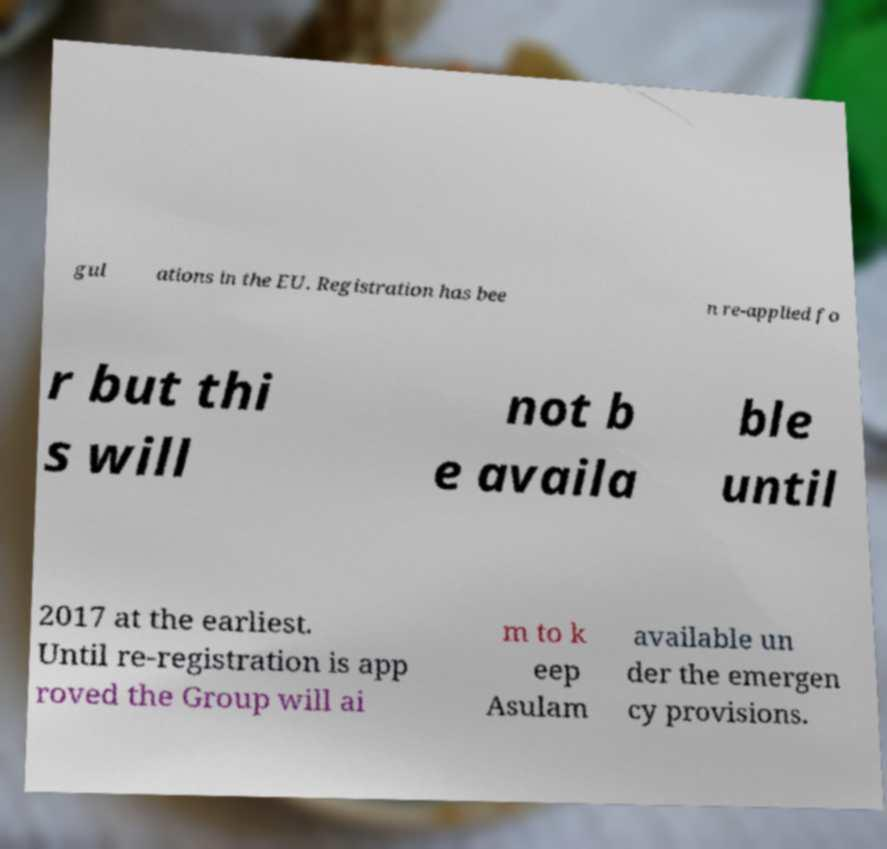There's text embedded in this image that I need extracted. Can you transcribe it verbatim? gul ations in the EU. Registration has bee n re-applied fo r but thi s will not b e availa ble until 2017 at the earliest. Until re-registration is app roved the Group will ai m to k eep Asulam available un der the emergen cy provisions. 